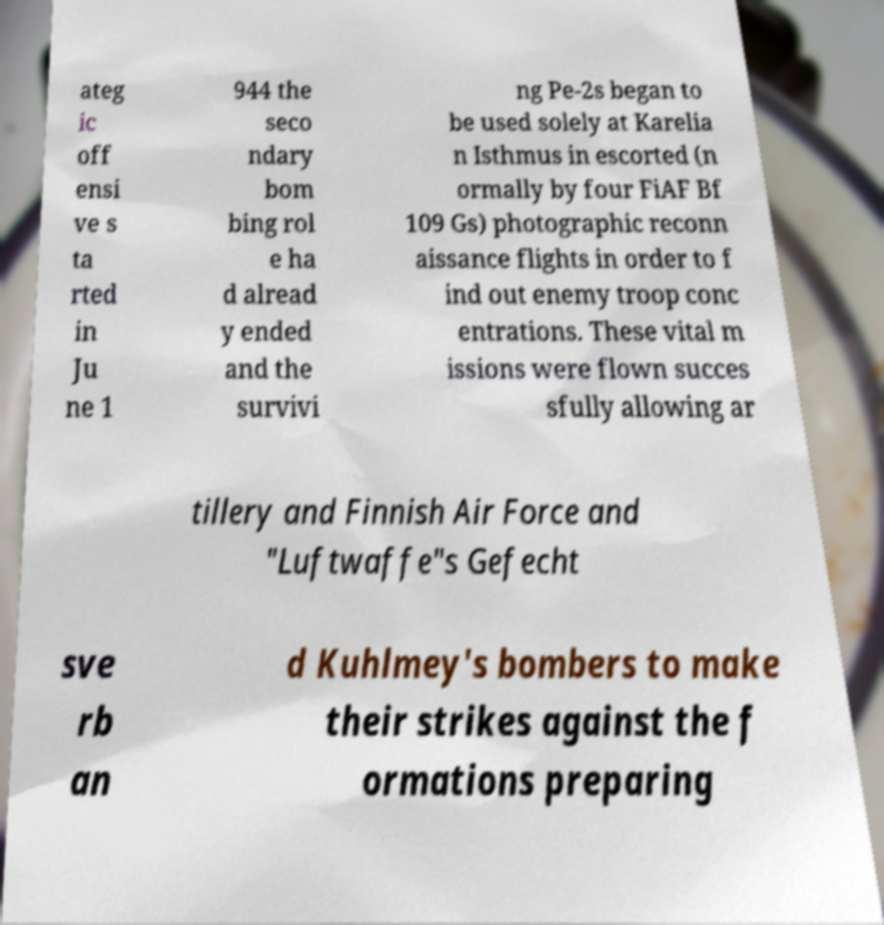What messages or text are displayed in this image? I need them in a readable, typed format. ateg ic off ensi ve s ta rted in Ju ne 1 944 the seco ndary bom bing rol e ha d alread y ended and the survivi ng Pe-2s began to be used solely at Karelia n Isthmus in escorted (n ormally by four FiAF Bf 109 Gs) photographic reconn aissance flights in order to f ind out enemy troop conc entrations. These vital m issions were flown succes sfully allowing ar tillery and Finnish Air Force and "Luftwaffe"s Gefecht sve rb an d Kuhlmey's bombers to make their strikes against the f ormations preparing 